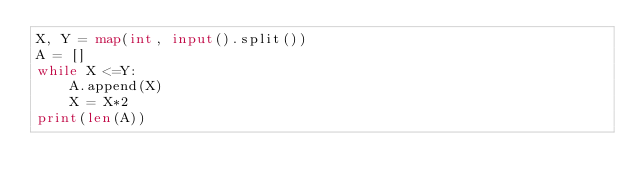Convert code to text. <code><loc_0><loc_0><loc_500><loc_500><_Python_>X, Y = map(int, input().split())
A = []
while X <=Y:
    A.append(X)
    X = X*2
print(len(A))

</code> 